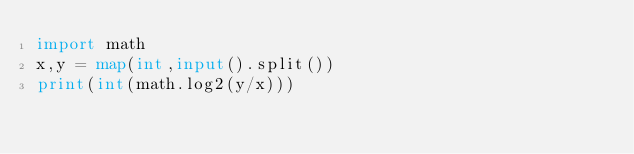Convert code to text. <code><loc_0><loc_0><loc_500><loc_500><_Python_>import math
x,y = map(int,input().split())
print(int(math.log2(y/x)))</code> 